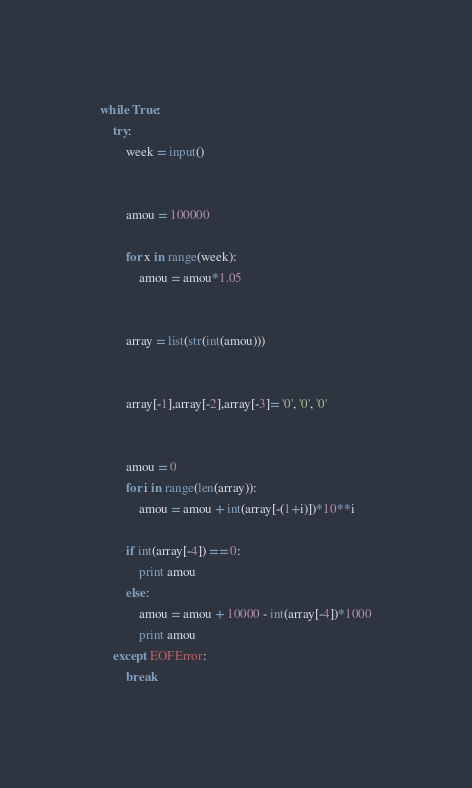<code> <loc_0><loc_0><loc_500><loc_500><_Python_>
while True:
    try:
        week = input()
        
        
        amou = 100000
        
        for x in range(week):
            amou = amou*1.05
        
        
        array = list(str(int(amou)))
        
        
        array[-1],array[-2],array[-3]= '0', '0', '0'
        
        
        amou = 0
        for i in range(len(array)):
            amou = amou + int(array[-(1+i)])*10**i
        
        if int(array[-4]) == 0:
            print amou
        else:
            amou = amou + 10000 - int(array[-4])*1000
            print amou
    except EOFError:
        break            </code> 